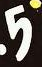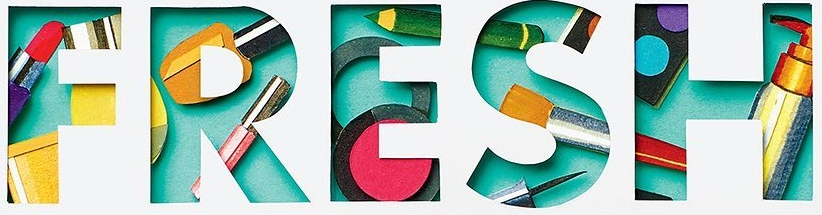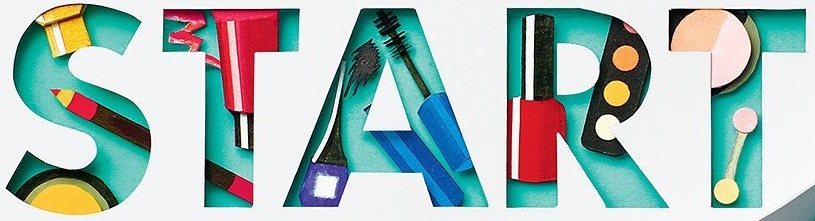What words are shown in these images in order, separated by a semicolon? 5; FRESH; START 